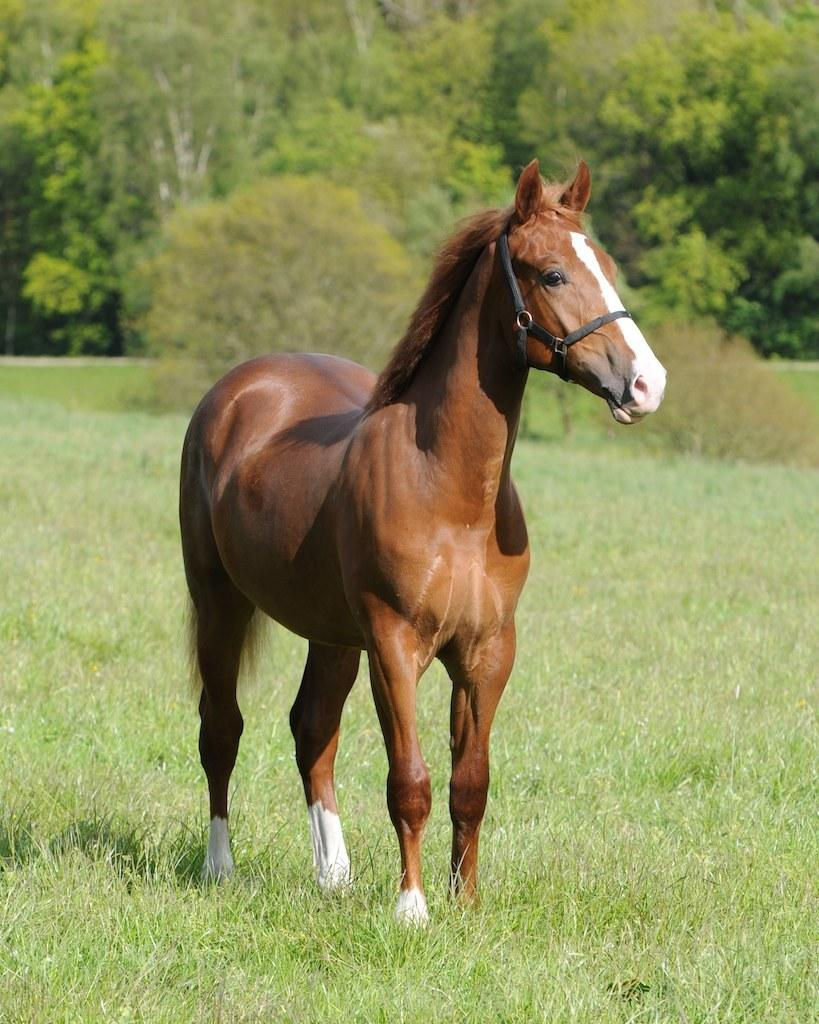What type of animal is in the image? There is a brown horse in the image. What is at the bottom of the image? There is green grass at the bottom of the image. What can be seen in the background of the image? There are trees and plants in the background of the image. What type of servant can be seen attending to the horse in the image? There is no servant present in the image; it only features a brown horse in a natural setting. 